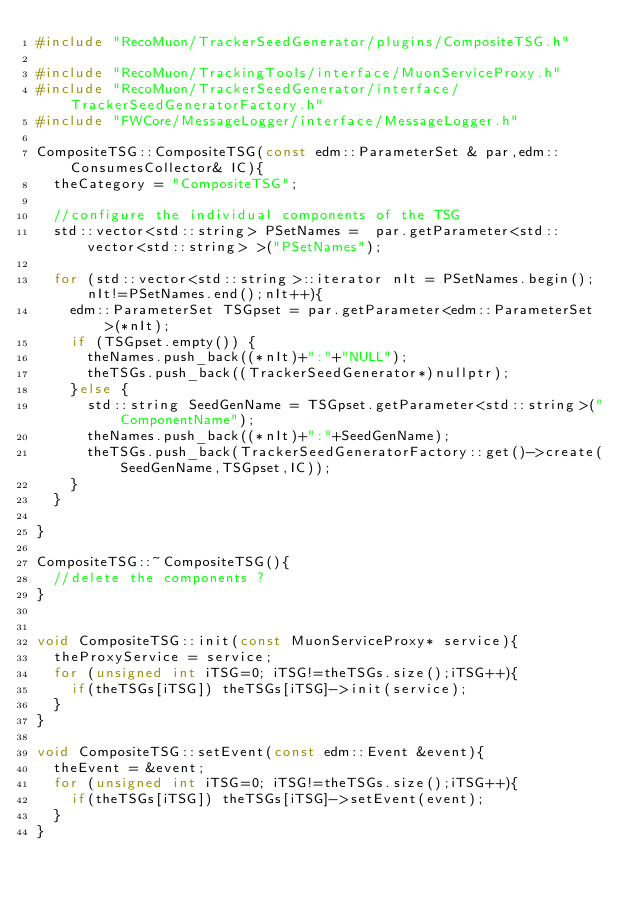<code> <loc_0><loc_0><loc_500><loc_500><_C++_>#include "RecoMuon/TrackerSeedGenerator/plugins/CompositeTSG.h"

#include "RecoMuon/TrackingTools/interface/MuonServiceProxy.h"
#include "RecoMuon/TrackerSeedGenerator/interface/TrackerSeedGeneratorFactory.h"
#include "FWCore/MessageLogger/interface/MessageLogger.h"

CompositeTSG::CompositeTSG(const edm::ParameterSet & par,edm::ConsumesCollector& IC){
  theCategory = "CompositeTSG";

  //configure the individual components of the TSG
  std::vector<std::string> PSetNames =  par.getParameter<std::vector<std::string> >("PSetNames");

  for (std::vector<std::string>::iterator nIt = PSetNames.begin();nIt!=PSetNames.end();nIt++){
    edm::ParameterSet TSGpset = par.getParameter<edm::ParameterSet>(*nIt);
    if (TSGpset.empty()) {
      theNames.push_back((*nIt)+":"+"NULL");
      theTSGs.push_back((TrackerSeedGenerator*)nullptr);
    }else {
      std::string SeedGenName = TSGpset.getParameter<std::string>("ComponentName");
      theNames.push_back((*nIt)+":"+SeedGenName);
      theTSGs.push_back(TrackerSeedGeneratorFactory::get()->create(SeedGenName,TSGpset,IC));
    }
  }
  
}

CompositeTSG::~CompositeTSG(){
  //delete the components ?
}


void CompositeTSG::init(const MuonServiceProxy* service){
  theProxyService = service;
  for (unsigned int iTSG=0; iTSG!=theTSGs.size();iTSG++){
    if(theTSGs[iTSG]) theTSGs[iTSG]->init(service);
  }
}

void CompositeTSG::setEvent(const edm::Event &event){
  theEvent = &event;
  for (unsigned int iTSG=0; iTSG!=theTSGs.size();iTSG++){
    if(theTSGs[iTSG]) theTSGs[iTSG]->setEvent(event);
  }
}
</code> 